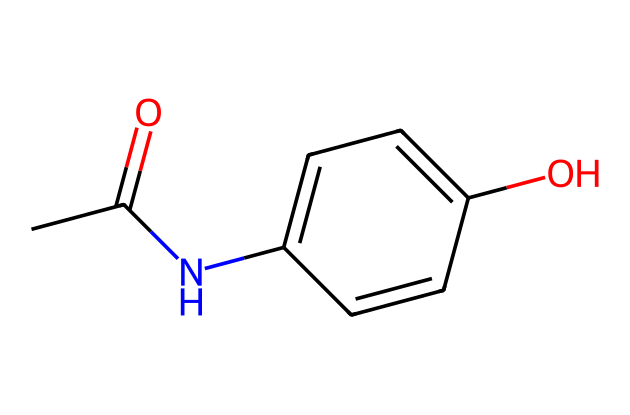What is the molecular formula of this compound? To find the molecular formula, count the number of each type of atom in the SMILES representation. It contains 8 carbon atoms (C), 9 hydrogen atoms (H), 1 nitrogen atom (N), and 1 oxygen atom (O). Therefore, the molecular formula is C8H9NO2.
Answer: C8H9NO2 How many rings are present in this structure? Analyzing the SMILES shows that there's one cyclic structure indicated by 'C1' and the corresponding closing 'C1' later on, which denotes a six-membered aromatic ring. Thus, there is one ring.
Answer: 1 What type of functional group is present in this compound? There are multiple functional groups present: an amide group (due to the nitrogen connected to the carbonyl carbon) and a hydroxyl group (due to the -OH). The prominent functional group influencing the properties is the amide group.
Answer: amide What is the primary purpose of this compound in medicine? Acetaminophen is primarily used as an analgesic (pain reliever) and antipyretic (fever reducer). Its main therapeutic action is to reduce fever and relieve minor aches and pains.
Answer: analgesic How many stereocenters does this compound have? A stereocenter is typically identified by the presence of a carbon atom bonded to four different groups. In the given structure, none of the carbon atoms fit this criterion, indicating there are no stereocenters.
Answer: 0 What type of drug category does acetaminophen belong to? Acetaminophen falls into the category of non-opioid analgesics, specifically as an over-the-counter pain-relief medication. It is known for its ability to relieve pain without the use of narcotic substances.
Answer: non-opioid analgesic 